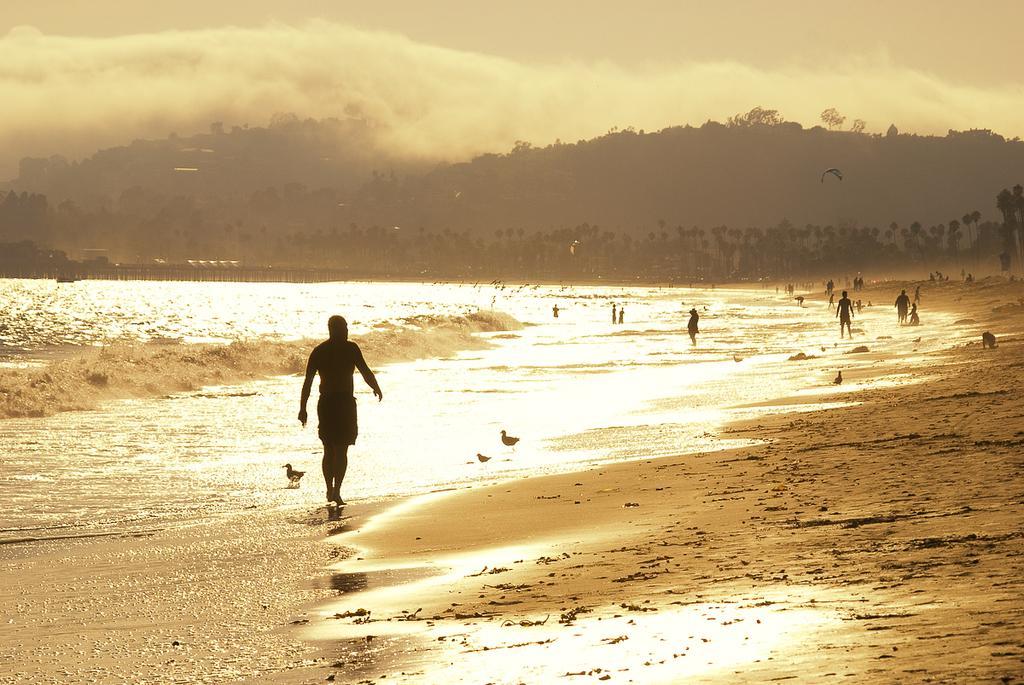In one or two sentences, can you explain what this image depicts? In this picture there is a man who is walking on the beach. Beside him I can see the birds. In the background I can see many people enjoying in the water and some people were sitting on the beach. In the background I can see the trees and mountains. At the top I can see the sky and clouds. On the left I can see the water. 